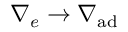<formula> <loc_0><loc_0><loc_500><loc_500>\nabla _ { e } \rightarrow \nabla _ { a d }</formula> 